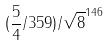<formula> <loc_0><loc_0><loc_500><loc_500>( \frac { 5 } { 4 } / 3 5 9 ) / \sqrt { 8 } ^ { 1 4 6 }</formula> 